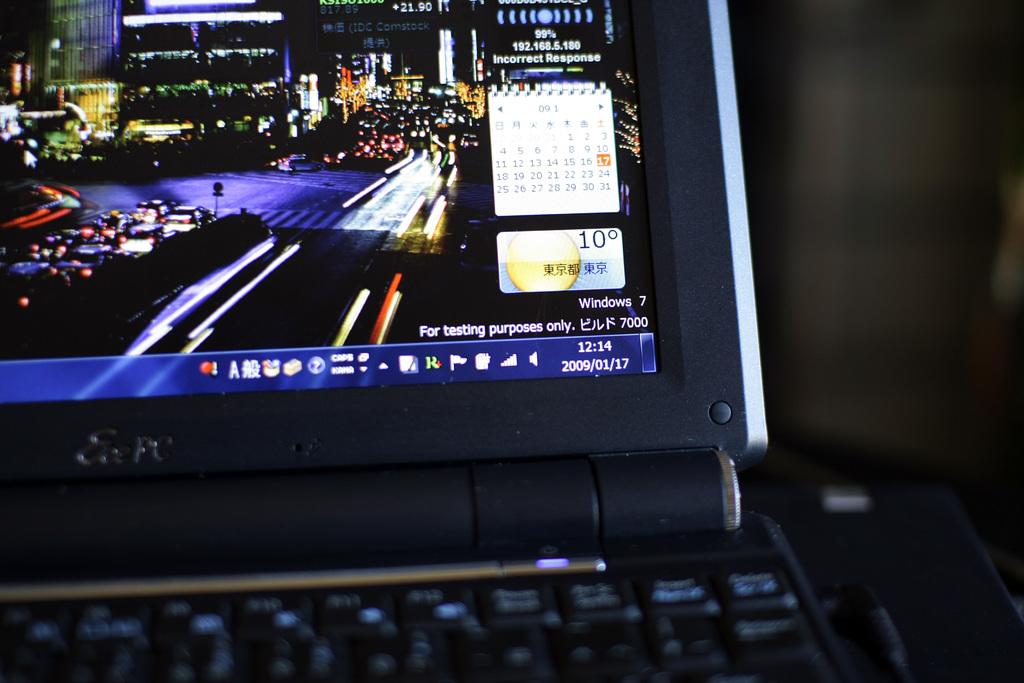What time is on the computer?
Provide a short and direct response. 12:14. 